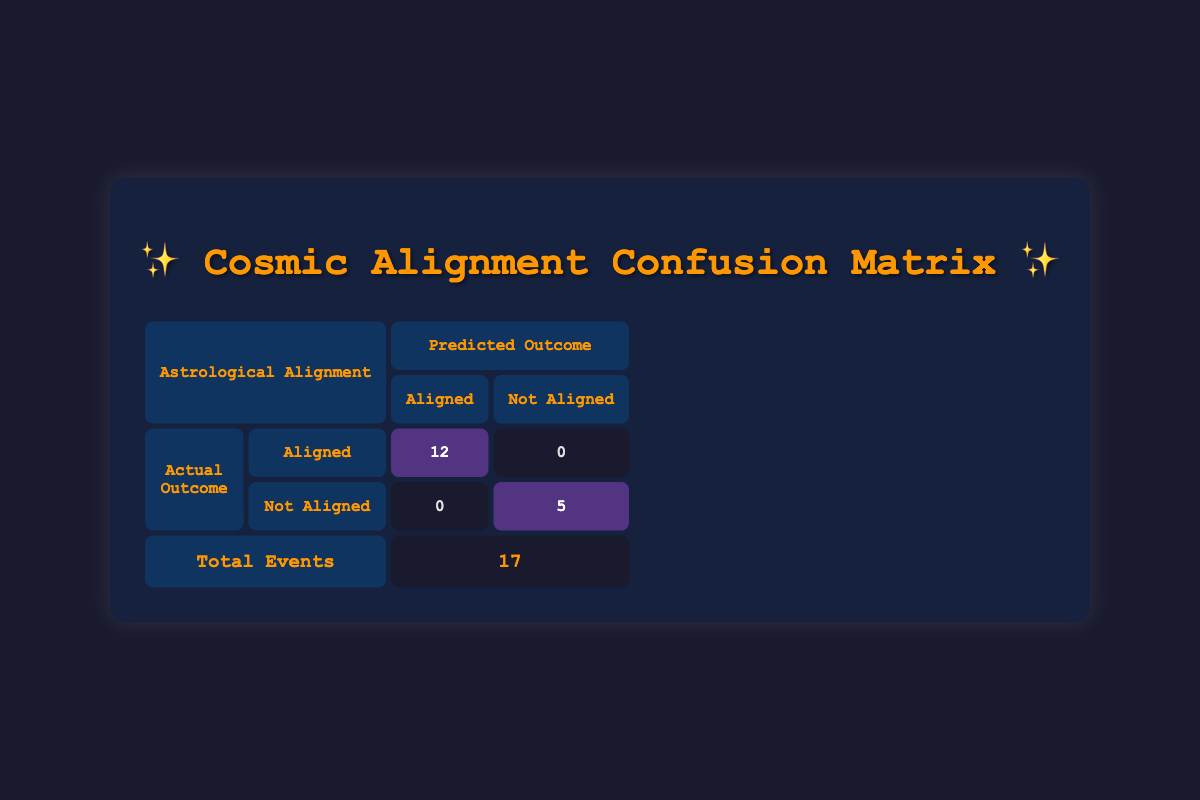What is the total number of aligned events? To find the total number of aligned events, we look at the highlighted area in the table under "Aligned" for the actual outcome. The number is 12.
Answer: 12 How many life events were not aligned with their astrological predictions? The bottom right cell labeled "Not Aligned" under "Not Aligned" shows 5, indicating that there were 5 life events that did not align with the astrological predictions.
Answer: 5 What is the total number of events predicted? We can find the total number of events by adding together the aligned and not aligned counts. This totals to (12 aligned + 5 not aligned) = 17 events in total.
Answer: 17 Was there ever a month where a life event occurred that did not align with its astrological prediction? Yes, there were 5 cases of misalignment in the table, as indicated by the "Not Aligned" section under actual outcomes, where the count is 5.
Answer: Yes How many months had both an aligned event and a not aligned event? Looking closely at the months, we see that "February," "April," "June," "September," and "October" are the months where events both aligned and did not align with predictions. Thus, the count is 5.
Answer: 5 What percentage of total life events were aligned with predictions? To calculate this, divide the number of aligned events (12) by the total events (17), then multiply by 100. So (12/17) * 100 = approximately 70.59%.
Answer: 70.59% What is the difference between the number of aligned and not aligned predictions? The difference is calculated by subtracting the not aligned events (5) from the aligned events (12), resulting in 12 - 5 = 7.
Answer: 7 Identify how many months had aligned events. By reviewing the rows under the "Aligned" section, it's clear that there are 12 aligned events corresponding to 12 individual months. Hence, the number of months is 12.
Answer: 12 